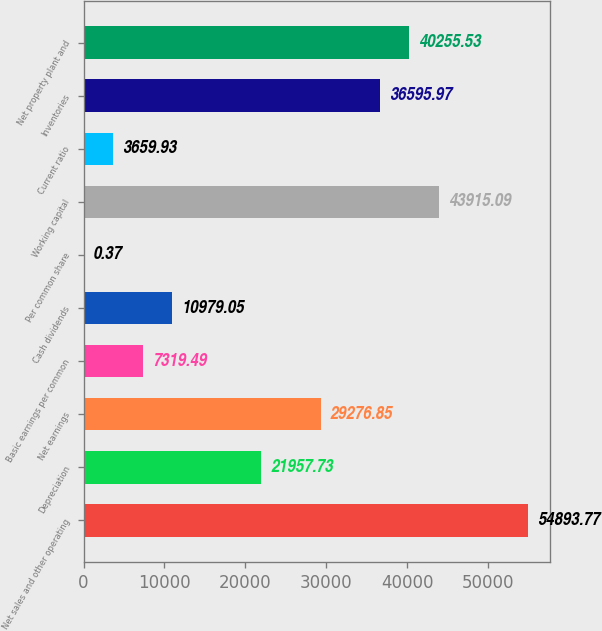<chart> <loc_0><loc_0><loc_500><loc_500><bar_chart><fcel>Net sales and other operating<fcel>Depreciation<fcel>Net earnings<fcel>Basic earnings per common<fcel>Cash dividends<fcel>Per common share<fcel>Working capital<fcel>Current ratio<fcel>Inventories<fcel>Net property plant and<nl><fcel>54893.8<fcel>21957.7<fcel>29276.8<fcel>7319.49<fcel>10979<fcel>0.37<fcel>43915.1<fcel>3659.93<fcel>36596<fcel>40255.5<nl></chart> 